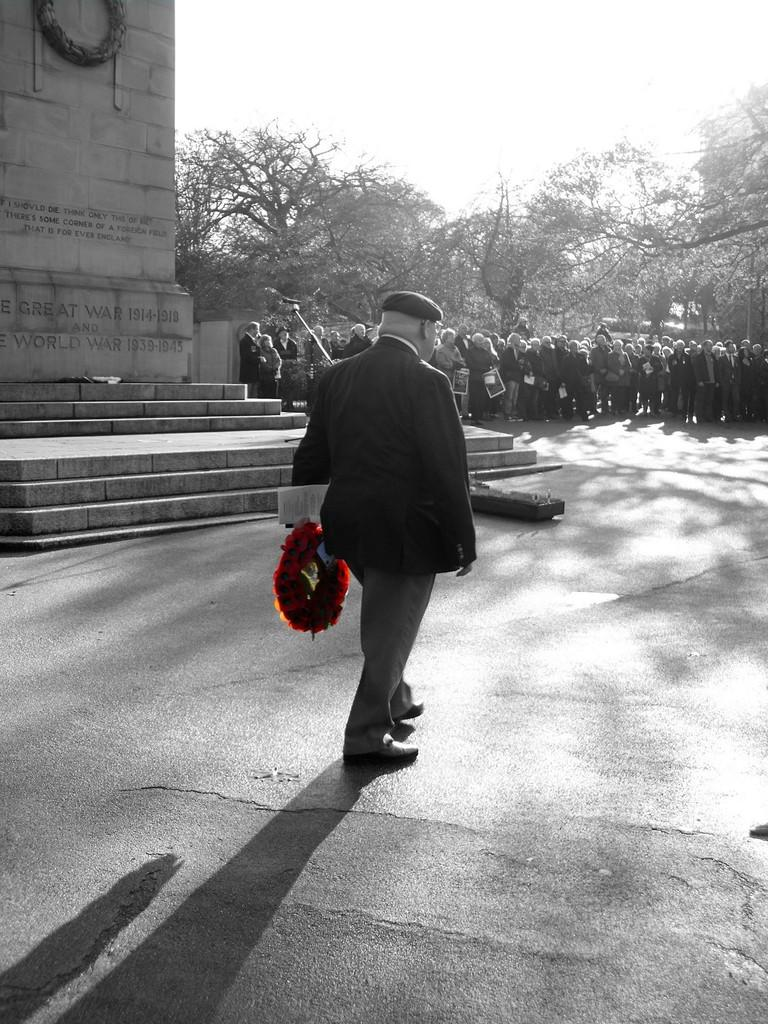What are the people in the image doing? The persons in the image are standing on the road. Can you describe what one of the persons is holding? One of the persons is holding a bouquet in their hands. What can be seen in the background of the image? In the background, there is a laid stone, a staircase, trees, and the sky. How many clocks are visible on the persons' bodies in the image? There are no clocks visible on the persons' bodies in the image. What type of box is being used to store the bouquet? There is no box present in the image; the bouquet is being held by one of the persons. 